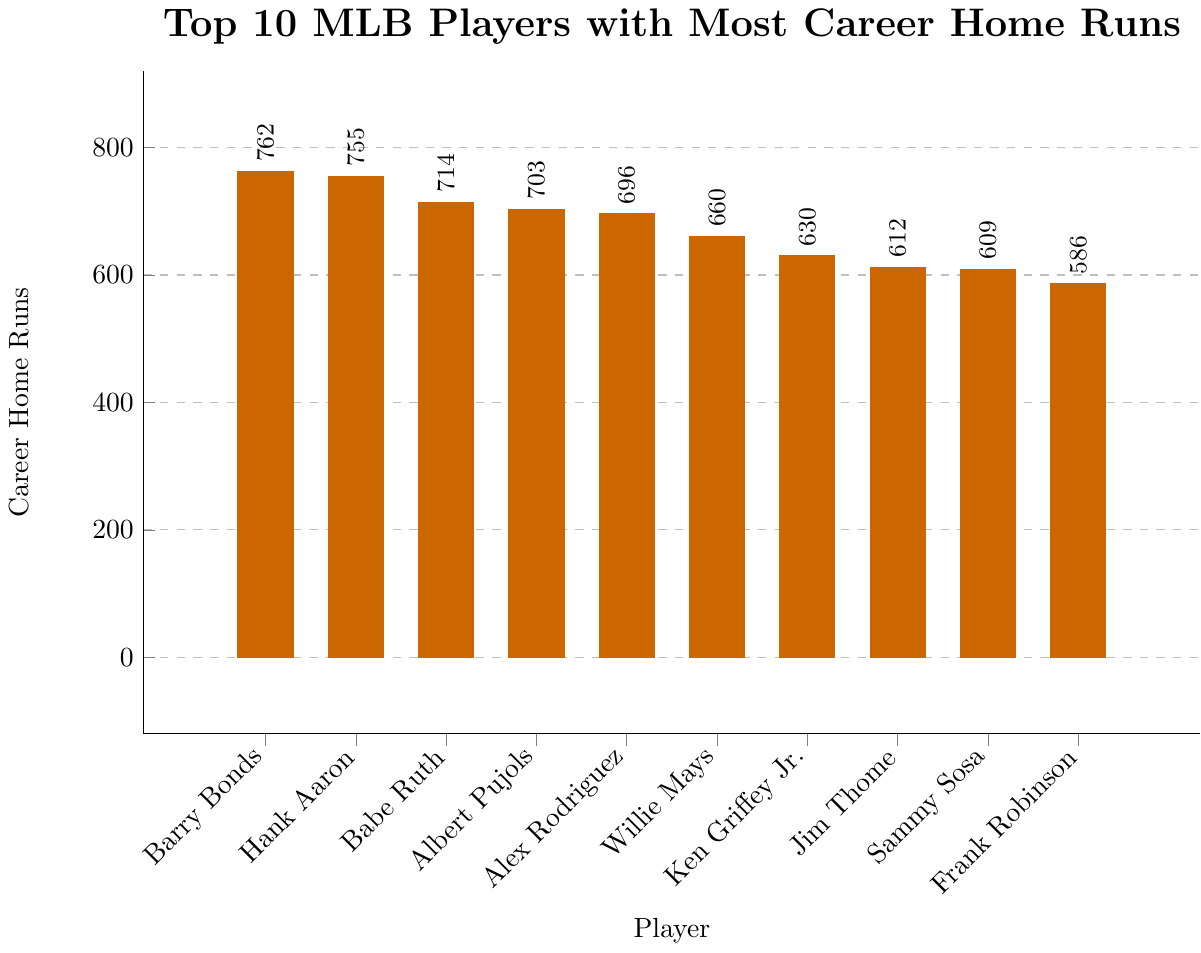Which player has the highest number of career home runs? The player with the tallest bar represents the highest number of career home runs. Barry Bonds has the tallest bar.
Answer: Barry Bonds How many more home runs does Babe Ruth have compared to Frank Robinson? Identify the bars corresponding to Babe Ruth and Frank Robinson. Babe Ruth's bar reaches 714, and Frank Robinson's bar reaches 586. Calculate the difference: 714 - 586 = 128.
Answer: 128 Who has more career home runs, Hank Aaron or Willie Mays? Compare the heights of Hank Aaron's bar and Willie Mays's bar. Hank Aaron's bar is higher, reaching 755, while Willie Mays's bar reaches 660.
Answer: Hank Aaron What is the total number of career home runs for Ken Griffey Jr. and Jim Thome combined? Identify the bars for Ken Griffey Jr. and Jim Thome. Ken Griffey Jr.'s bar reaches 630, and Jim Thome's bar reaches 612. Add the two values: 630 + 612 = 1242.
Answer: 1242 Which two players have career home run counts closest to each other? Visually identify the bars with similar heights. Alex Rodriguez and Willie Mays appear close. Checking the figures confirms: Alex Rodriguez has 696, Willie Mays has 660. The difference is 36.
Answer: Alex Rodriguez and Willie Mays How many players have more than 700 career home runs? Count the number of bars that extend above the 700 mark on the y-axis. There are four players: Barry Bonds, Hank Aaron, Babe Ruth, and Albert Pujols.
Answer: 4 If you combine the career home runs of the top 2 players, what percent of the total career home runs for all ten players do they represent? Sum the top 2 players' home runs: Barry Bonds (762) + Hank Aaron (755) = 1517. Then sum the total home runs of all ten players: 762 + 755 + 714 + 703 + 696 + 660 + 630 + 612 + 609 + 586 = 6727. Calculate the percent: (1517 / 6727) * 100 ≈ 22.54%.
Answer: ~22.54% What is the difference in career home runs between the player ranked 1st and the player ranked 10th? Barry Bonds is ranked 1st with 762 home runs, and Frank Robinson is ranked 10th with 586 home runs. The difference is 762 - 586 = 176.
Answer: 176 